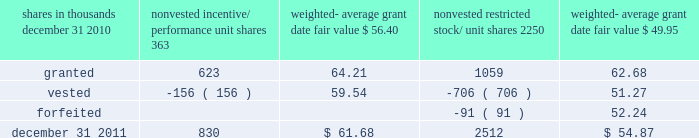There were no options granted in excess of market value in 2011 , 2010 or 2009 .
Shares of common stock available during the next year for the granting of options and other awards under the incentive plans were 33775543 at december 31 , 2011 .
Total shares of pnc common stock authorized for future issuance under equity compensation plans totaled 35304422 shares at december 31 , 2011 , which includes shares available for issuance under the incentive plans and the employee stock purchase plan ( espp ) as described below .
During 2011 , we issued 731336 shares from treasury stock in connection with stock option exercise activity .
As with past exercise activity , we currently intend to utilize primarily treasury stock for any future stock option exercises .
Awards granted to non-employee directors in 2011 , 2010 and 2009 include 27090 , 29040 , and 39552 deferred stock units , respectively , awarded under the outside directors deferred stock unit plan .
A deferred stock unit is a phantom share of our common stock , which requires liability accounting treatment until such awards are paid to the participants as cash .
As there are no vesting or service requirements on these awards , total compensation expense is recognized in full on awarded deferred stock units on the date of grant .
Incentive/performance unit share awards and restricted stock/unit awards the fair value of nonvested incentive/performance unit share awards and restricted stock/unit awards is initially determined based on prices not less than the market value of our common stock price on the date of grant .
The value of certain incentive/ performance unit share awards is subsequently remeasured based on the achievement of one or more financial and other performance goals generally over a three-year period .
The personnel and compensation committee of the board of directors approves the final award payout with respect to incentive/performance unit share awards .
Restricted stock/unit awards have various vesting periods generally ranging from 36 months to 60 months .
Beginning in 2011 , we incorporated two changes to certain awards under our existing long-term incentive compensation programs .
First , for certain grants of incentive performance units , the future payout amount will be subject to a negative annual adjustment if pnc fails to meet certain risk-related performance metrics .
This adjustment is in addition to the existing financial performance metrics relative to our peers .
These grants have a three-year performance period and are payable in either stock or a combination of stock and cash .
Second , performance-based restricted share units ( performance rsus ) were granted in 2011 to certain of our executives in lieu of stock options .
These performance rsus ( which are payable solely in stock ) have a service condition , an internal risk-related performance condition , and an external market condition .
Satisfaction of the performance condition is based on four independent one-year performance periods .
The weighted-average grant-date fair value of incentive/ performance unit share awards and restricted stock/unit awards granted in 2011 , 2010 and 2009 was $ 63.25 , $ 54.59 and $ 41.16 per share , respectively .
We recognize compensation expense for such awards ratably over the corresponding vesting and/or performance periods for each type of program .
Nonvested incentive/performance unit share awards and restricted stock/unit awards 2013 rollforward shares in thousands nonvested incentive/ performance unit shares weighted- average date fair nonvested restricted stock/ shares weighted- average date fair .
In the chart above , the unit shares and related weighted- average grant-date fair value of the incentive/performance awards exclude the effect of dividends on the underlying shares , as those dividends will be paid in cash .
At december 31 , 2011 , there was $ 61 million of unrecognized deferred compensation expense related to nonvested share- based compensation arrangements granted under the incentive plans .
This cost is expected to be recognized as expense over a period of no longer than five years .
The total fair value of incentive/performance unit share and restricted stock/unit awards vested during 2011 , 2010 and 2009 was approximately $ 52 million , $ 39 million and $ 47 million , respectively .
Liability awards we grant annually cash-payable restricted share units to certain executives .
The grants were made primarily as part of an annual bonus incentive deferral plan .
While there are time- based and service-related vesting criteria , there are no market or performance criteria associated with these awards .
Compensation expense recognized related to these awards was recorded in prior periods as part of annual cash bonus criteria .
As of december 31 , 2011 , there were 753203 of these cash- payable restricted share units outstanding .
174 the pnc financial services group , inc .
2013 form 10-k .
In 2011 , what percentage of common stocks were issued from treasury stock from stock option activity? 
Computations: (731336 / 33775543)
Answer: 0.02165. 